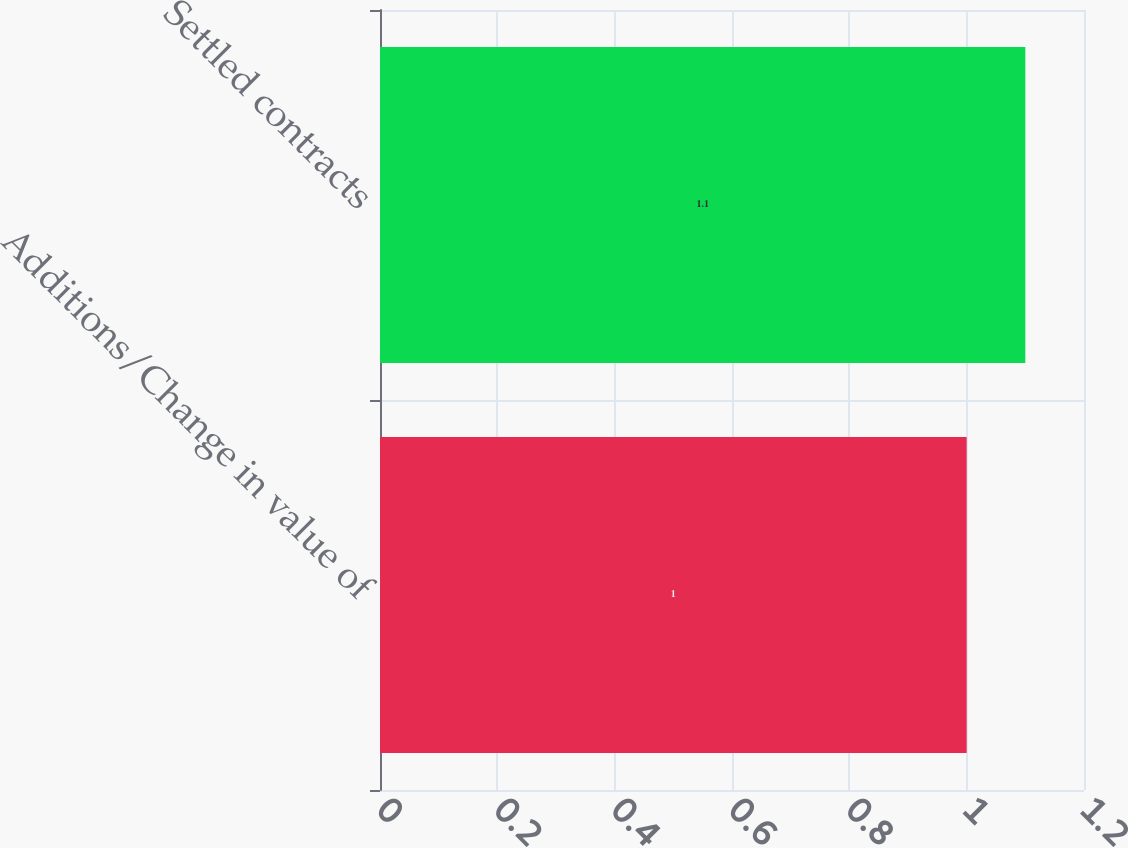<chart> <loc_0><loc_0><loc_500><loc_500><bar_chart><fcel>Additions/Change in value of<fcel>Settled contracts<nl><fcel>1<fcel>1.1<nl></chart> 